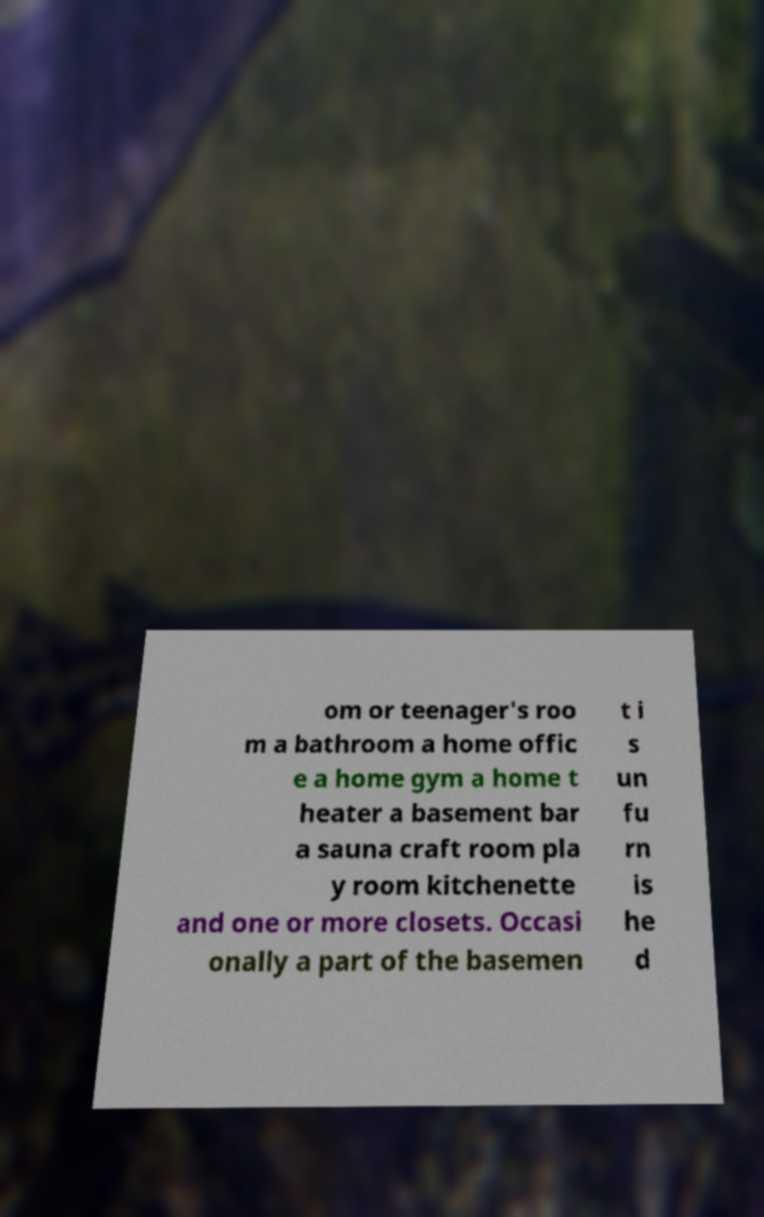Please read and relay the text visible in this image. What does it say? om or teenager's roo m a bathroom a home offic e a home gym a home t heater a basement bar a sauna craft room pla y room kitchenette and one or more closets. Occasi onally a part of the basemen t i s un fu rn is he d 